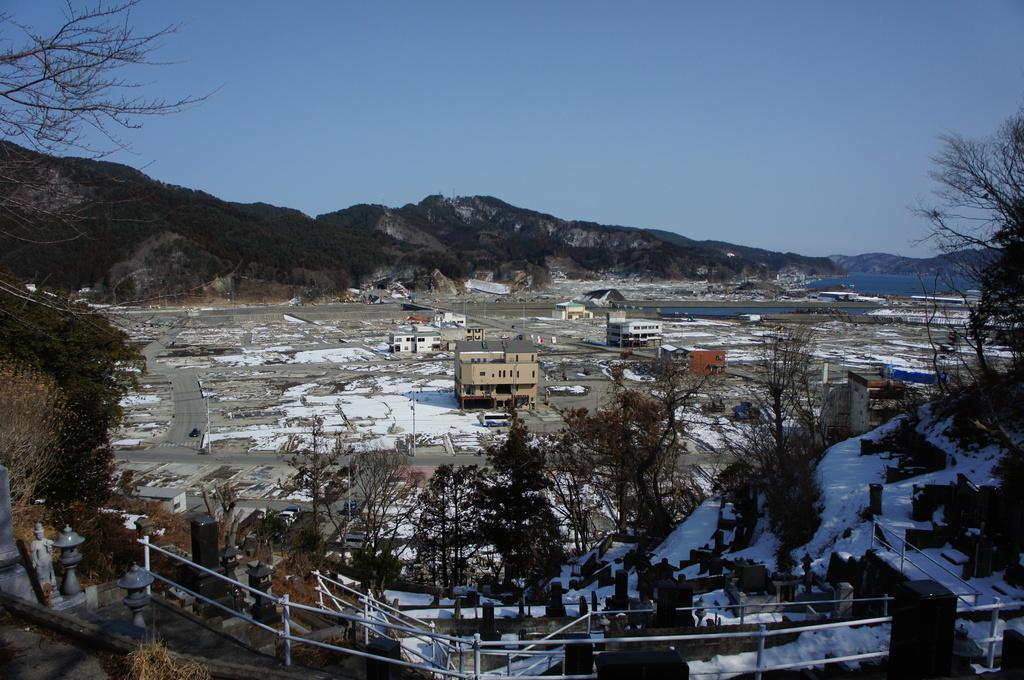Can you describe this image briefly? In n this image there are many trees, buildings. In the foreground there are fences. In the background there are trees, hills. On the ground there is snow. The sky is clear. 